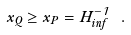Convert formula to latex. <formula><loc_0><loc_0><loc_500><loc_500>x _ { Q } \geq x _ { P } = H _ { i n f } ^ { - 1 } \ .</formula> 